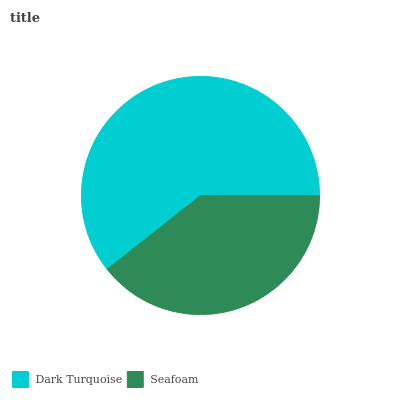Is Seafoam the minimum?
Answer yes or no. Yes. Is Dark Turquoise the maximum?
Answer yes or no. Yes. Is Seafoam the maximum?
Answer yes or no. No. Is Dark Turquoise greater than Seafoam?
Answer yes or no. Yes. Is Seafoam less than Dark Turquoise?
Answer yes or no. Yes. Is Seafoam greater than Dark Turquoise?
Answer yes or no. No. Is Dark Turquoise less than Seafoam?
Answer yes or no. No. Is Dark Turquoise the high median?
Answer yes or no. Yes. Is Seafoam the low median?
Answer yes or no. Yes. Is Seafoam the high median?
Answer yes or no. No. Is Dark Turquoise the low median?
Answer yes or no. No. 